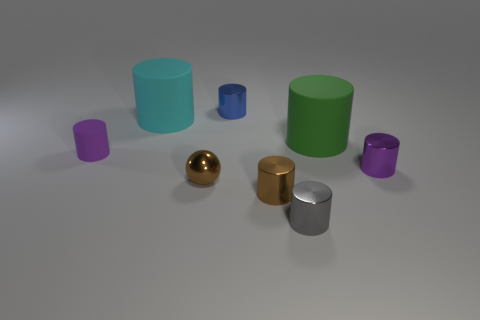Does the purple matte object have the same shape as the large green matte thing? yes 